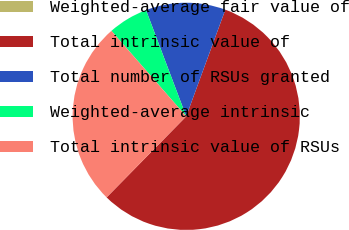<chart> <loc_0><loc_0><loc_500><loc_500><pie_chart><fcel>Weighted-average fair value of<fcel>Total intrinsic value of<fcel>Total number of RSUs granted<fcel>Weighted-average intrinsic<fcel>Total intrinsic value of RSUs<nl><fcel>0.0%<fcel>56.77%<fcel>11.35%<fcel>5.68%<fcel>26.2%<nl></chart> 